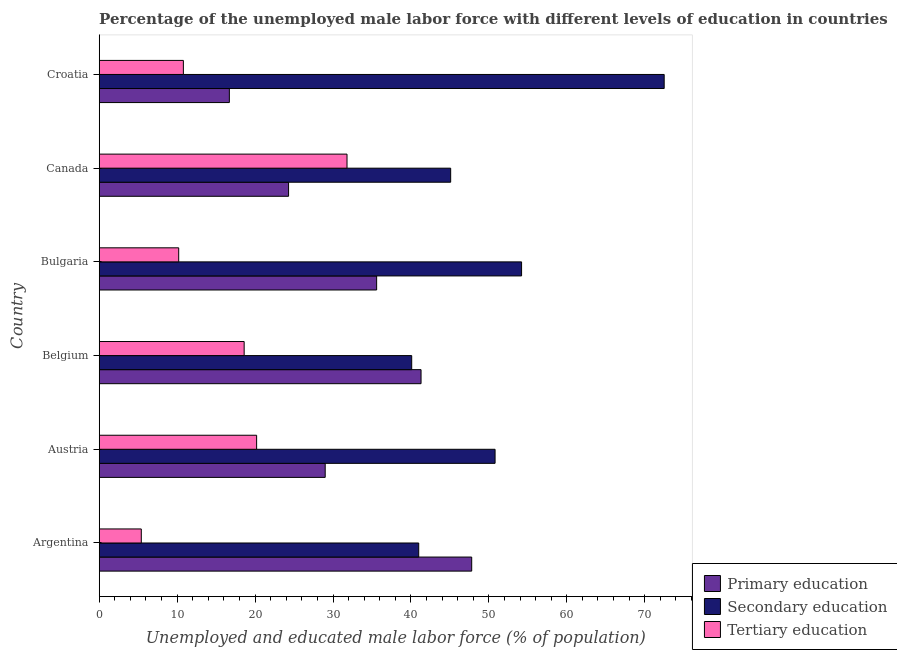How many groups of bars are there?
Make the answer very short. 6. Are the number of bars per tick equal to the number of legend labels?
Your response must be concise. Yes. Are the number of bars on each tick of the Y-axis equal?
Offer a very short reply. Yes. How many bars are there on the 5th tick from the bottom?
Keep it short and to the point. 3. In how many cases, is the number of bars for a given country not equal to the number of legend labels?
Provide a short and direct response. 0. What is the percentage of male labor force who received tertiary education in Argentina?
Your answer should be very brief. 5.4. Across all countries, what is the maximum percentage of male labor force who received primary education?
Your response must be concise. 47.8. Across all countries, what is the minimum percentage of male labor force who received tertiary education?
Ensure brevity in your answer.  5.4. In which country was the percentage of male labor force who received primary education maximum?
Keep it short and to the point. Argentina. In which country was the percentage of male labor force who received secondary education minimum?
Provide a short and direct response. Belgium. What is the total percentage of male labor force who received secondary education in the graph?
Your answer should be very brief. 303.7. What is the difference between the percentage of male labor force who received tertiary education in Argentina and that in Bulgaria?
Make the answer very short. -4.8. What is the difference between the percentage of male labor force who received secondary education in Argentina and the percentage of male labor force who received primary education in Croatia?
Offer a terse response. 24.3. What is the average percentage of male labor force who received tertiary education per country?
Make the answer very short. 16.17. What is the difference between the percentage of male labor force who received tertiary education and percentage of male labor force who received secondary education in Belgium?
Provide a succinct answer. -21.5. What is the ratio of the percentage of male labor force who received primary education in Bulgaria to that in Croatia?
Make the answer very short. 2.13. Is the percentage of male labor force who received secondary education in Argentina less than that in Croatia?
Make the answer very short. Yes. Is the difference between the percentage of male labor force who received secondary education in Austria and Croatia greater than the difference between the percentage of male labor force who received primary education in Austria and Croatia?
Keep it short and to the point. No. What is the difference between the highest and the second highest percentage of male labor force who received primary education?
Ensure brevity in your answer.  6.5. What is the difference between the highest and the lowest percentage of male labor force who received primary education?
Provide a short and direct response. 31.1. What does the 1st bar from the top in Austria represents?
Provide a succinct answer. Tertiary education. What does the 3rd bar from the bottom in Croatia represents?
Keep it short and to the point. Tertiary education. Is it the case that in every country, the sum of the percentage of male labor force who received primary education and percentage of male labor force who received secondary education is greater than the percentage of male labor force who received tertiary education?
Your response must be concise. Yes. How many bars are there?
Ensure brevity in your answer.  18. How many countries are there in the graph?
Keep it short and to the point. 6. Are the values on the major ticks of X-axis written in scientific E-notation?
Provide a succinct answer. No. Where does the legend appear in the graph?
Make the answer very short. Bottom right. How are the legend labels stacked?
Keep it short and to the point. Vertical. What is the title of the graph?
Keep it short and to the point. Percentage of the unemployed male labor force with different levels of education in countries. What is the label or title of the X-axis?
Ensure brevity in your answer.  Unemployed and educated male labor force (% of population). What is the Unemployed and educated male labor force (% of population) of Primary education in Argentina?
Keep it short and to the point. 47.8. What is the Unemployed and educated male labor force (% of population) in Tertiary education in Argentina?
Keep it short and to the point. 5.4. What is the Unemployed and educated male labor force (% of population) of Secondary education in Austria?
Your answer should be compact. 50.8. What is the Unemployed and educated male labor force (% of population) of Tertiary education in Austria?
Make the answer very short. 20.2. What is the Unemployed and educated male labor force (% of population) in Primary education in Belgium?
Provide a short and direct response. 41.3. What is the Unemployed and educated male labor force (% of population) of Secondary education in Belgium?
Ensure brevity in your answer.  40.1. What is the Unemployed and educated male labor force (% of population) in Tertiary education in Belgium?
Your response must be concise. 18.6. What is the Unemployed and educated male labor force (% of population) in Primary education in Bulgaria?
Keep it short and to the point. 35.6. What is the Unemployed and educated male labor force (% of population) in Secondary education in Bulgaria?
Your response must be concise. 54.2. What is the Unemployed and educated male labor force (% of population) in Tertiary education in Bulgaria?
Offer a terse response. 10.2. What is the Unemployed and educated male labor force (% of population) in Primary education in Canada?
Your answer should be very brief. 24.3. What is the Unemployed and educated male labor force (% of population) of Secondary education in Canada?
Your response must be concise. 45.1. What is the Unemployed and educated male labor force (% of population) of Tertiary education in Canada?
Offer a very short reply. 31.8. What is the Unemployed and educated male labor force (% of population) in Primary education in Croatia?
Your answer should be compact. 16.7. What is the Unemployed and educated male labor force (% of population) in Secondary education in Croatia?
Keep it short and to the point. 72.5. What is the Unemployed and educated male labor force (% of population) of Tertiary education in Croatia?
Your answer should be very brief. 10.8. Across all countries, what is the maximum Unemployed and educated male labor force (% of population) of Primary education?
Give a very brief answer. 47.8. Across all countries, what is the maximum Unemployed and educated male labor force (% of population) in Secondary education?
Give a very brief answer. 72.5. Across all countries, what is the maximum Unemployed and educated male labor force (% of population) of Tertiary education?
Provide a short and direct response. 31.8. Across all countries, what is the minimum Unemployed and educated male labor force (% of population) of Primary education?
Your answer should be very brief. 16.7. Across all countries, what is the minimum Unemployed and educated male labor force (% of population) of Secondary education?
Offer a terse response. 40.1. Across all countries, what is the minimum Unemployed and educated male labor force (% of population) in Tertiary education?
Offer a terse response. 5.4. What is the total Unemployed and educated male labor force (% of population) of Primary education in the graph?
Provide a short and direct response. 194.7. What is the total Unemployed and educated male labor force (% of population) of Secondary education in the graph?
Keep it short and to the point. 303.7. What is the total Unemployed and educated male labor force (% of population) of Tertiary education in the graph?
Offer a terse response. 97. What is the difference between the Unemployed and educated male labor force (% of population) in Primary education in Argentina and that in Austria?
Offer a terse response. 18.8. What is the difference between the Unemployed and educated male labor force (% of population) of Tertiary education in Argentina and that in Austria?
Make the answer very short. -14.8. What is the difference between the Unemployed and educated male labor force (% of population) of Primary education in Argentina and that in Belgium?
Your answer should be very brief. 6.5. What is the difference between the Unemployed and educated male labor force (% of population) of Secondary education in Argentina and that in Belgium?
Provide a short and direct response. 0.9. What is the difference between the Unemployed and educated male labor force (% of population) of Primary education in Argentina and that in Canada?
Provide a succinct answer. 23.5. What is the difference between the Unemployed and educated male labor force (% of population) of Tertiary education in Argentina and that in Canada?
Your answer should be compact. -26.4. What is the difference between the Unemployed and educated male labor force (% of population) in Primary education in Argentina and that in Croatia?
Your response must be concise. 31.1. What is the difference between the Unemployed and educated male labor force (% of population) of Secondary education in Argentina and that in Croatia?
Ensure brevity in your answer.  -31.5. What is the difference between the Unemployed and educated male labor force (% of population) of Tertiary education in Argentina and that in Croatia?
Your answer should be compact. -5.4. What is the difference between the Unemployed and educated male labor force (% of population) of Secondary education in Austria and that in Belgium?
Make the answer very short. 10.7. What is the difference between the Unemployed and educated male labor force (% of population) in Tertiary education in Austria and that in Bulgaria?
Ensure brevity in your answer.  10. What is the difference between the Unemployed and educated male labor force (% of population) in Primary education in Austria and that in Canada?
Your answer should be very brief. 4.7. What is the difference between the Unemployed and educated male labor force (% of population) of Tertiary education in Austria and that in Canada?
Your answer should be compact. -11.6. What is the difference between the Unemployed and educated male labor force (% of population) in Secondary education in Austria and that in Croatia?
Give a very brief answer. -21.7. What is the difference between the Unemployed and educated male labor force (% of population) in Tertiary education in Austria and that in Croatia?
Give a very brief answer. 9.4. What is the difference between the Unemployed and educated male labor force (% of population) in Secondary education in Belgium and that in Bulgaria?
Your answer should be compact. -14.1. What is the difference between the Unemployed and educated male labor force (% of population) of Tertiary education in Belgium and that in Bulgaria?
Offer a very short reply. 8.4. What is the difference between the Unemployed and educated male labor force (% of population) in Primary education in Belgium and that in Canada?
Ensure brevity in your answer.  17. What is the difference between the Unemployed and educated male labor force (% of population) in Secondary education in Belgium and that in Canada?
Make the answer very short. -5. What is the difference between the Unemployed and educated male labor force (% of population) of Primary education in Belgium and that in Croatia?
Give a very brief answer. 24.6. What is the difference between the Unemployed and educated male labor force (% of population) in Secondary education in Belgium and that in Croatia?
Provide a succinct answer. -32.4. What is the difference between the Unemployed and educated male labor force (% of population) of Primary education in Bulgaria and that in Canada?
Keep it short and to the point. 11.3. What is the difference between the Unemployed and educated male labor force (% of population) in Tertiary education in Bulgaria and that in Canada?
Provide a succinct answer. -21.6. What is the difference between the Unemployed and educated male labor force (% of population) of Secondary education in Bulgaria and that in Croatia?
Your answer should be very brief. -18.3. What is the difference between the Unemployed and educated male labor force (% of population) in Primary education in Canada and that in Croatia?
Your response must be concise. 7.6. What is the difference between the Unemployed and educated male labor force (% of population) in Secondary education in Canada and that in Croatia?
Provide a succinct answer. -27.4. What is the difference between the Unemployed and educated male labor force (% of population) in Primary education in Argentina and the Unemployed and educated male labor force (% of population) in Tertiary education in Austria?
Offer a terse response. 27.6. What is the difference between the Unemployed and educated male labor force (% of population) in Secondary education in Argentina and the Unemployed and educated male labor force (% of population) in Tertiary education in Austria?
Your answer should be very brief. 20.8. What is the difference between the Unemployed and educated male labor force (% of population) in Primary education in Argentina and the Unemployed and educated male labor force (% of population) in Tertiary education in Belgium?
Give a very brief answer. 29.2. What is the difference between the Unemployed and educated male labor force (% of population) of Secondary education in Argentina and the Unemployed and educated male labor force (% of population) of Tertiary education in Belgium?
Ensure brevity in your answer.  22.4. What is the difference between the Unemployed and educated male labor force (% of population) of Primary education in Argentina and the Unemployed and educated male labor force (% of population) of Secondary education in Bulgaria?
Keep it short and to the point. -6.4. What is the difference between the Unemployed and educated male labor force (% of population) in Primary education in Argentina and the Unemployed and educated male labor force (% of population) in Tertiary education in Bulgaria?
Ensure brevity in your answer.  37.6. What is the difference between the Unemployed and educated male labor force (% of population) of Secondary education in Argentina and the Unemployed and educated male labor force (% of population) of Tertiary education in Bulgaria?
Offer a terse response. 30.8. What is the difference between the Unemployed and educated male labor force (% of population) in Secondary education in Argentina and the Unemployed and educated male labor force (% of population) in Tertiary education in Canada?
Make the answer very short. 9.2. What is the difference between the Unemployed and educated male labor force (% of population) in Primary education in Argentina and the Unemployed and educated male labor force (% of population) in Secondary education in Croatia?
Ensure brevity in your answer.  -24.7. What is the difference between the Unemployed and educated male labor force (% of population) of Secondary education in Argentina and the Unemployed and educated male labor force (% of population) of Tertiary education in Croatia?
Make the answer very short. 30.2. What is the difference between the Unemployed and educated male labor force (% of population) of Primary education in Austria and the Unemployed and educated male labor force (% of population) of Secondary education in Belgium?
Keep it short and to the point. -11.1. What is the difference between the Unemployed and educated male labor force (% of population) of Primary education in Austria and the Unemployed and educated male labor force (% of population) of Tertiary education in Belgium?
Offer a very short reply. 10.4. What is the difference between the Unemployed and educated male labor force (% of population) of Secondary education in Austria and the Unemployed and educated male labor force (% of population) of Tertiary education in Belgium?
Your response must be concise. 32.2. What is the difference between the Unemployed and educated male labor force (% of population) of Primary education in Austria and the Unemployed and educated male labor force (% of population) of Secondary education in Bulgaria?
Offer a terse response. -25.2. What is the difference between the Unemployed and educated male labor force (% of population) in Secondary education in Austria and the Unemployed and educated male labor force (% of population) in Tertiary education in Bulgaria?
Offer a terse response. 40.6. What is the difference between the Unemployed and educated male labor force (% of population) of Primary education in Austria and the Unemployed and educated male labor force (% of population) of Secondary education in Canada?
Provide a succinct answer. -16.1. What is the difference between the Unemployed and educated male labor force (% of population) of Primary education in Austria and the Unemployed and educated male labor force (% of population) of Secondary education in Croatia?
Keep it short and to the point. -43.5. What is the difference between the Unemployed and educated male labor force (% of population) in Primary education in Austria and the Unemployed and educated male labor force (% of population) in Tertiary education in Croatia?
Keep it short and to the point. 18.2. What is the difference between the Unemployed and educated male labor force (% of population) of Secondary education in Austria and the Unemployed and educated male labor force (% of population) of Tertiary education in Croatia?
Provide a succinct answer. 40. What is the difference between the Unemployed and educated male labor force (% of population) of Primary education in Belgium and the Unemployed and educated male labor force (% of population) of Tertiary education in Bulgaria?
Provide a short and direct response. 31.1. What is the difference between the Unemployed and educated male labor force (% of population) in Secondary education in Belgium and the Unemployed and educated male labor force (% of population) in Tertiary education in Bulgaria?
Your response must be concise. 29.9. What is the difference between the Unemployed and educated male labor force (% of population) in Primary education in Belgium and the Unemployed and educated male labor force (% of population) in Secondary education in Canada?
Offer a very short reply. -3.8. What is the difference between the Unemployed and educated male labor force (% of population) of Primary education in Belgium and the Unemployed and educated male labor force (% of population) of Tertiary education in Canada?
Your answer should be compact. 9.5. What is the difference between the Unemployed and educated male labor force (% of population) of Primary education in Belgium and the Unemployed and educated male labor force (% of population) of Secondary education in Croatia?
Keep it short and to the point. -31.2. What is the difference between the Unemployed and educated male labor force (% of population) in Primary education in Belgium and the Unemployed and educated male labor force (% of population) in Tertiary education in Croatia?
Ensure brevity in your answer.  30.5. What is the difference between the Unemployed and educated male labor force (% of population) in Secondary education in Belgium and the Unemployed and educated male labor force (% of population) in Tertiary education in Croatia?
Keep it short and to the point. 29.3. What is the difference between the Unemployed and educated male labor force (% of population) of Primary education in Bulgaria and the Unemployed and educated male labor force (% of population) of Secondary education in Canada?
Give a very brief answer. -9.5. What is the difference between the Unemployed and educated male labor force (% of population) in Secondary education in Bulgaria and the Unemployed and educated male labor force (% of population) in Tertiary education in Canada?
Offer a terse response. 22.4. What is the difference between the Unemployed and educated male labor force (% of population) in Primary education in Bulgaria and the Unemployed and educated male labor force (% of population) in Secondary education in Croatia?
Provide a succinct answer. -36.9. What is the difference between the Unemployed and educated male labor force (% of population) of Primary education in Bulgaria and the Unemployed and educated male labor force (% of population) of Tertiary education in Croatia?
Ensure brevity in your answer.  24.8. What is the difference between the Unemployed and educated male labor force (% of population) of Secondary education in Bulgaria and the Unemployed and educated male labor force (% of population) of Tertiary education in Croatia?
Your response must be concise. 43.4. What is the difference between the Unemployed and educated male labor force (% of population) of Primary education in Canada and the Unemployed and educated male labor force (% of population) of Secondary education in Croatia?
Ensure brevity in your answer.  -48.2. What is the difference between the Unemployed and educated male labor force (% of population) of Secondary education in Canada and the Unemployed and educated male labor force (% of population) of Tertiary education in Croatia?
Your answer should be compact. 34.3. What is the average Unemployed and educated male labor force (% of population) in Primary education per country?
Ensure brevity in your answer.  32.45. What is the average Unemployed and educated male labor force (% of population) in Secondary education per country?
Offer a very short reply. 50.62. What is the average Unemployed and educated male labor force (% of population) in Tertiary education per country?
Your answer should be very brief. 16.17. What is the difference between the Unemployed and educated male labor force (% of population) of Primary education and Unemployed and educated male labor force (% of population) of Secondary education in Argentina?
Keep it short and to the point. 6.8. What is the difference between the Unemployed and educated male labor force (% of population) of Primary education and Unemployed and educated male labor force (% of population) of Tertiary education in Argentina?
Offer a very short reply. 42.4. What is the difference between the Unemployed and educated male labor force (% of population) of Secondary education and Unemployed and educated male labor force (% of population) of Tertiary education in Argentina?
Ensure brevity in your answer.  35.6. What is the difference between the Unemployed and educated male labor force (% of population) of Primary education and Unemployed and educated male labor force (% of population) of Secondary education in Austria?
Your answer should be very brief. -21.8. What is the difference between the Unemployed and educated male labor force (% of population) of Primary education and Unemployed and educated male labor force (% of population) of Tertiary education in Austria?
Provide a short and direct response. 8.8. What is the difference between the Unemployed and educated male labor force (% of population) of Secondary education and Unemployed and educated male labor force (% of population) of Tertiary education in Austria?
Your answer should be compact. 30.6. What is the difference between the Unemployed and educated male labor force (% of population) in Primary education and Unemployed and educated male labor force (% of population) in Tertiary education in Belgium?
Make the answer very short. 22.7. What is the difference between the Unemployed and educated male labor force (% of population) of Secondary education and Unemployed and educated male labor force (% of population) of Tertiary education in Belgium?
Your answer should be very brief. 21.5. What is the difference between the Unemployed and educated male labor force (% of population) of Primary education and Unemployed and educated male labor force (% of population) of Secondary education in Bulgaria?
Provide a succinct answer. -18.6. What is the difference between the Unemployed and educated male labor force (% of population) in Primary education and Unemployed and educated male labor force (% of population) in Tertiary education in Bulgaria?
Keep it short and to the point. 25.4. What is the difference between the Unemployed and educated male labor force (% of population) of Primary education and Unemployed and educated male labor force (% of population) of Secondary education in Canada?
Give a very brief answer. -20.8. What is the difference between the Unemployed and educated male labor force (% of population) in Primary education and Unemployed and educated male labor force (% of population) in Tertiary education in Canada?
Give a very brief answer. -7.5. What is the difference between the Unemployed and educated male labor force (% of population) in Secondary education and Unemployed and educated male labor force (% of population) in Tertiary education in Canada?
Give a very brief answer. 13.3. What is the difference between the Unemployed and educated male labor force (% of population) in Primary education and Unemployed and educated male labor force (% of population) in Secondary education in Croatia?
Ensure brevity in your answer.  -55.8. What is the difference between the Unemployed and educated male labor force (% of population) in Secondary education and Unemployed and educated male labor force (% of population) in Tertiary education in Croatia?
Give a very brief answer. 61.7. What is the ratio of the Unemployed and educated male labor force (% of population) in Primary education in Argentina to that in Austria?
Your response must be concise. 1.65. What is the ratio of the Unemployed and educated male labor force (% of population) of Secondary education in Argentina to that in Austria?
Your answer should be very brief. 0.81. What is the ratio of the Unemployed and educated male labor force (% of population) of Tertiary education in Argentina to that in Austria?
Ensure brevity in your answer.  0.27. What is the ratio of the Unemployed and educated male labor force (% of population) in Primary education in Argentina to that in Belgium?
Offer a terse response. 1.16. What is the ratio of the Unemployed and educated male labor force (% of population) in Secondary education in Argentina to that in Belgium?
Provide a short and direct response. 1.02. What is the ratio of the Unemployed and educated male labor force (% of population) of Tertiary education in Argentina to that in Belgium?
Your answer should be very brief. 0.29. What is the ratio of the Unemployed and educated male labor force (% of population) of Primary education in Argentina to that in Bulgaria?
Give a very brief answer. 1.34. What is the ratio of the Unemployed and educated male labor force (% of population) in Secondary education in Argentina to that in Bulgaria?
Your answer should be compact. 0.76. What is the ratio of the Unemployed and educated male labor force (% of population) in Tertiary education in Argentina to that in Bulgaria?
Offer a terse response. 0.53. What is the ratio of the Unemployed and educated male labor force (% of population) in Primary education in Argentina to that in Canada?
Your answer should be compact. 1.97. What is the ratio of the Unemployed and educated male labor force (% of population) in Secondary education in Argentina to that in Canada?
Offer a terse response. 0.91. What is the ratio of the Unemployed and educated male labor force (% of population) in Tertiary education in Argentina to that in Canada?
Keep it short and to the point. 0.17. What is the ratio of the Unemployed and educated male labor force (% of population) of Primary education in Argentina to that in Croatia?
Ensure brevity in your answer.  2.86. What is the ratio of the Unemployed and educated male labor force (% of population) in Secondary education in Argentina to that in Croatia?
Give a very brief answer. 0.57. What is the ratio of the Unemployed and educated male labor force (% of population) of Tertiary education in Argentina to that in Croatia?
Give a very brief answer. 0.5. What is the ratio of the Unemployed and educated male labor force (% of population) of Primary education in Austria to that in Belgium?
Offer a terse response. 0.7. What is the ratio of the Unemployed and educated male labor force (% of population) in Secondary education in Austria to that in Belgium?
Keep it short and to the point. 1.27. What is the ratio of the Unemployed and educated male labor force (% of population) of Tertiary education in Austria to that in Belgium?
Make the answer very short. 1.09. What is the ratio of the Unemployed and educated male labor force (% of population) of Primary education in Austria to that in Bulgaria?
Make the answer very short. 0.81. What is the ratio of the Unemployed and educated male labor force (% of population) in Secondary education in Austria to that in Bulgaria?
Give a very brief answer. 0.94. What is the ratio of the Unemployed and educated male labor force (% of population) in Tertiary education in Austria to that in Bulgaria?
Provide a short and direct response. 1.98. What is the ratio of the Unemployed and educated male labor force (% of population) of Primary education in Austria to that in Canada?
Provide a short and direct response. 1.19. What is the ratio of the Unemployed and educated male labor force (% of population) of Secondary education in Austria to that in Canada?
Keep it short and to the point. 1.13. What is the ratio of the Unemployed and educated male labor force (% of population) in Tertiary education in Austria to that in Canada?
Give a very brief answer. 0.64. What is the ratio of the Unemployed and educated male labor force (% of population) in Primary education in Austria to that in Croatia?
Your response must be concise. 1.74. What is the ratio of the Unemployed and educated male labor force (% of population) of Secondary education in Austria to that in Croatia?
Provide a short and direct response. 0.7. What is the ratio of the Unemployed and educated male labor force (% of population) of Tertiary education in Austria to that in Croatia?
Your response must be concise. 1.87. What is the ratio of the Unemployed and educated male labor force (% of population) of Primary education in Belgium to that in Bulgaria?
Provide a short and direct response. 1.16. What is the ratio of the Unemployed and educated male labor force (% of population) of Secondary education in Belgium to that in Bulgaria?
Ensure brevity in your answer.  0.74. What is the ratio of the Unemployed and educated male labor force (% of population) of Tertiary education in Belgium to that in Bulgaria?
Make the answer very short. 1.82. What is the ratio of the Unemployed and educated male labor force (% of population) in Primary education in Belgium to that in Canada?
Provide a succinct answer. 1.7. What is the ratio of the Unemployed and educated male labor force (% of population) of Secondary education in Belgium to that in Canada?
Give a very brief answer. 0.89. What is the ratio of the Unemployed and educated male labor force (% of population) of Tertiary education in Belgium to that in Canada?
Make the answer very short. 0.58. What is the ratio of the Unemployed and educated male labor force (% of population) in Primary education in Belgium to that in Croatia?
Keep it short and to the point. 2.47. What is the ratio of the Unemployed and educated male labor force (% of population) in Secondary education in Belgium to that in Croatia?
Your response must be concise. 0.55. What is the ratio of the Unemployed and educated male labor force (% of population) in Tertiary education in Belgium to that in Croatia?
Provide a short and direct response. 1.72. What is the ratio of the Unemployed and educated male labor force (% of population) of Primary education in Bulgaria to that in Canada?
Your response must be concise. 1.47. What is the ratio of the Unemployed and educated male labor force (% of population) of Secondary education in Bulgaria to that in Canada?
Ensure brevity in your answer.  1.2. What is the ratio of the Unemployed and educated male labor force (% of population) of Tertiary education in Bulgaria to that in Canada?
Ensure brevity in your answer.  0.32. What is the ratio of the Unemployed and educated male labor force (% of population) of Primary education in Bulgaria to that in Croatia?
Give a very brief answer. 2.13. What is the ratio of the Unemployed and educated male labor force (% of population) of Secondary education in Bulgaria to that in Croatia?
Make the answer very short. 0.75. What is the ratio of the Unemployed and educated male labor force (% of population) in Tertiary education in Bulgaria to that in Croatia?
Provide a short and direct response. 0.94. What is the ratio of the Unemployed and educated male labor force (% of population) of Primary education in Canada to that in Croatia?
Offer a very short reply. 1.46. What is the ratio of the Unemployed and educated male labor force (% of population) of Secondary education in Canada to that in Croatia?
Offer a terse response. 0.62. What is the ratio of the Unemployed and educated male labor force (% of population) in Tertiary education in Canada to that in Croatia?
Offer a terse response. 2.94. What is the difference between the highest and the second highest Unemployed and educated male labor force (% of population) of Secondary education?
Your response must be concise. 18.3. What is the difference between the highest and the second highest Unemployed and educated male labor force (% of population) in Tertiary education?
Your response must be concise. 11.6. What is the difference between the highest and the lowest Unemployed and educated male labor force (% of population) in Primary education?
Offer a very short reply. 31.1. What is the difference between the highest and the lowest Unemployed and educated male labor force (% of population) of Secondary education?
Offer a terse response. 32.4. What is the difference between the highest and the lowest Unemployed and educated male labor force (% of population) of Tertiary education?
Make the answer very short. 26.4. 